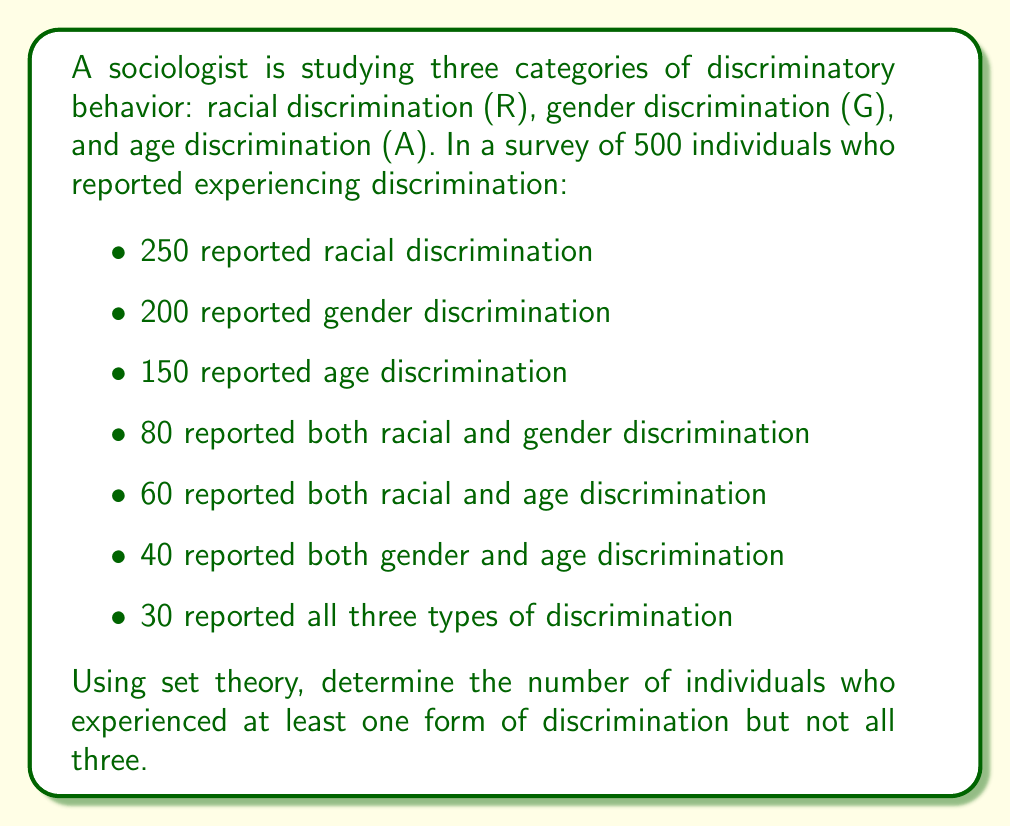Provide a solution to this math problem. To solve this problem, we'll use the principle of inclusion-exclusion from set theory. Let's break it down step-by-step:

1) First, let's define our sets:
   R: individuals experiencing racial discrimination
   G: individuals experiencing gender discrimination
   A: individuals experiencing age discrimination

2) We're given the following information:
   $|R| = 250$, $|G| = 200$, $|A| = 150$
   $|R \cap G| = 80$, $|R \cap A| = 60$, $|G \cap A| = 40$
   $|R \cap G \cap A| = 30$

3) The principle of inclusion-exclusion states:
   $|R \cup G \cup A| = |R| + |G| + |A| - |R \cap G| - |R \cap A| - |G \cap A| + |R \cap G \cap A|$

4) Substituting our values:
   $|R \cup G \cup A| = 250 + 200 + 150 - 80 - 60 - 40 + 30 = 450$

5) This gives us the total number of individuals who experienced at least one form of discrimination.

6) To find those who experienced at least one form but not all three, we subtract those who experienced all three:
   $450 - 30 = 420$

Therefore, 420 individuals experienced at least one form of discrimination but not all three.
Answer: 420 individuals 